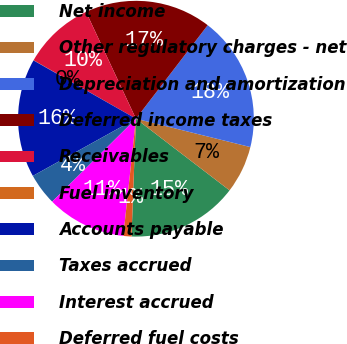Convert chart. <chart><loc_0><loc_0><loc_500><loc_500><pie_chart><fcel>Net income<fcel>Other regulatory charges - net<fcel>Depreciation and amortization<fcel>Deferred income taxes<fcel>Receivables<fcel>Fuel inventory<fcel>Accounts payable<fcel>Taxes accrued<fcel>Interest accrued<fcel>Deferred fuel costs<nl><fcel>15.2%<fcel>6.53%<fcel>18.45%<fcel>17.37%<fcel>9.78%<fcel>0.03%<fcel>16.29%<fcel>4.36%<fcel>10.87%<fcel>1.11%<nl></chart> 